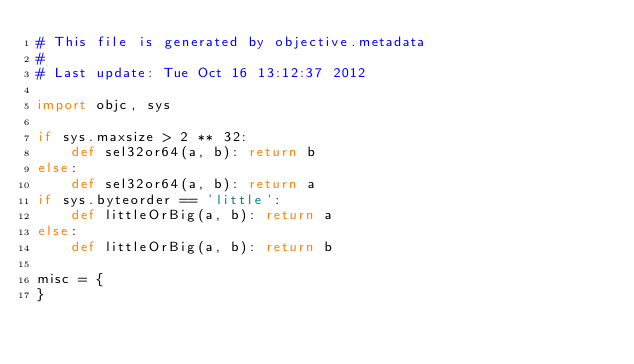Convert code to text. <code><loc_0><loc_0><loc_500><loc_500><_Python_># This file is generated by objective.metadata
#
# Last update: Tue Oct 16 13:12:37 2012

import objc, sys

if sys.maxsize > 2 ** 32:
    def sel32or64(a, b): return b
else:
    def sel32or64(a, b): return a
if sys.byteorder == 'little':
    def littleOrBig(a, b): return a
else:
    def littleOrBig(a, b): return b

misc = {
}</code> 